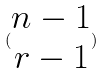Convert formula to latex. <formula><loc_0><loc_0><loc_500><loc_500>( \begin{matrix} n - 1 \\ r - 1 \end{matrix} )</formula> 